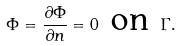Convert formula to latex. <formula><loc_0><loc_0><loc_500><loc_500>\Phi = \frac { \partial \Phi } { \partial n } = 0 \text { on } \Gamma .</formula> 